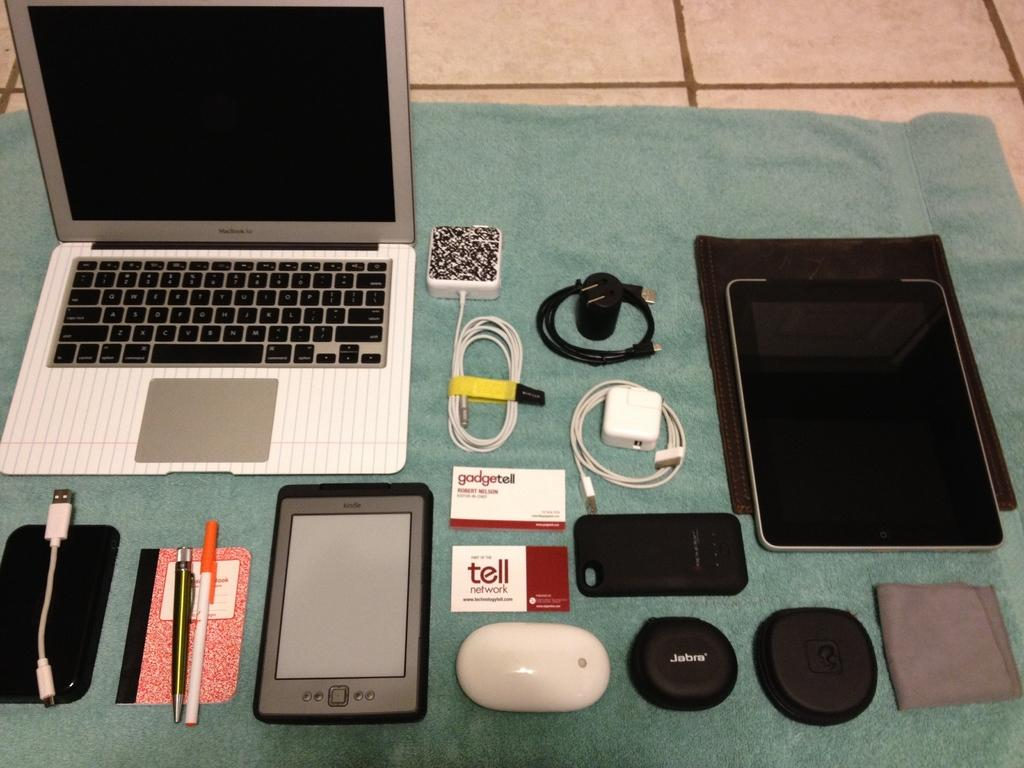Provide a one-sentence caption for the provided image. An open Macbook is surrounded by peripherals and a Kindle. 